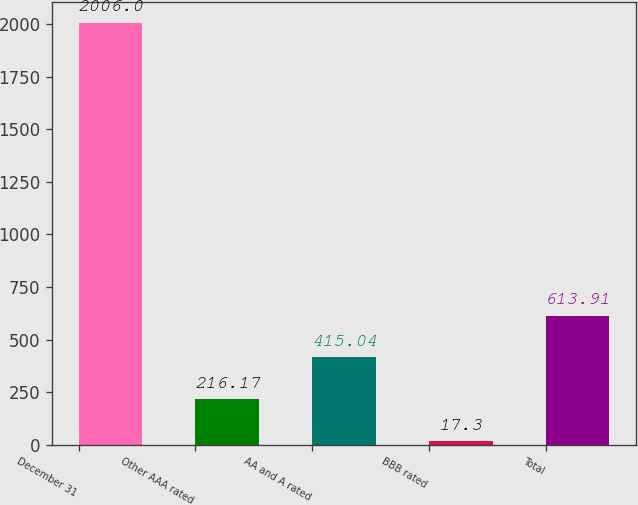Convert chart. <chart><loc_0><loc_0><loc_500><loc_500><bar_chart><fcel>December 31<fcel>Other AAA rated<fcel>AA and A rated<fcel>BBB rated<fcel>Total<nl><fcel>2006<fcel>216.17<fcel>415.04<fcel>17.3<fcel>613.91<nl></chart> 